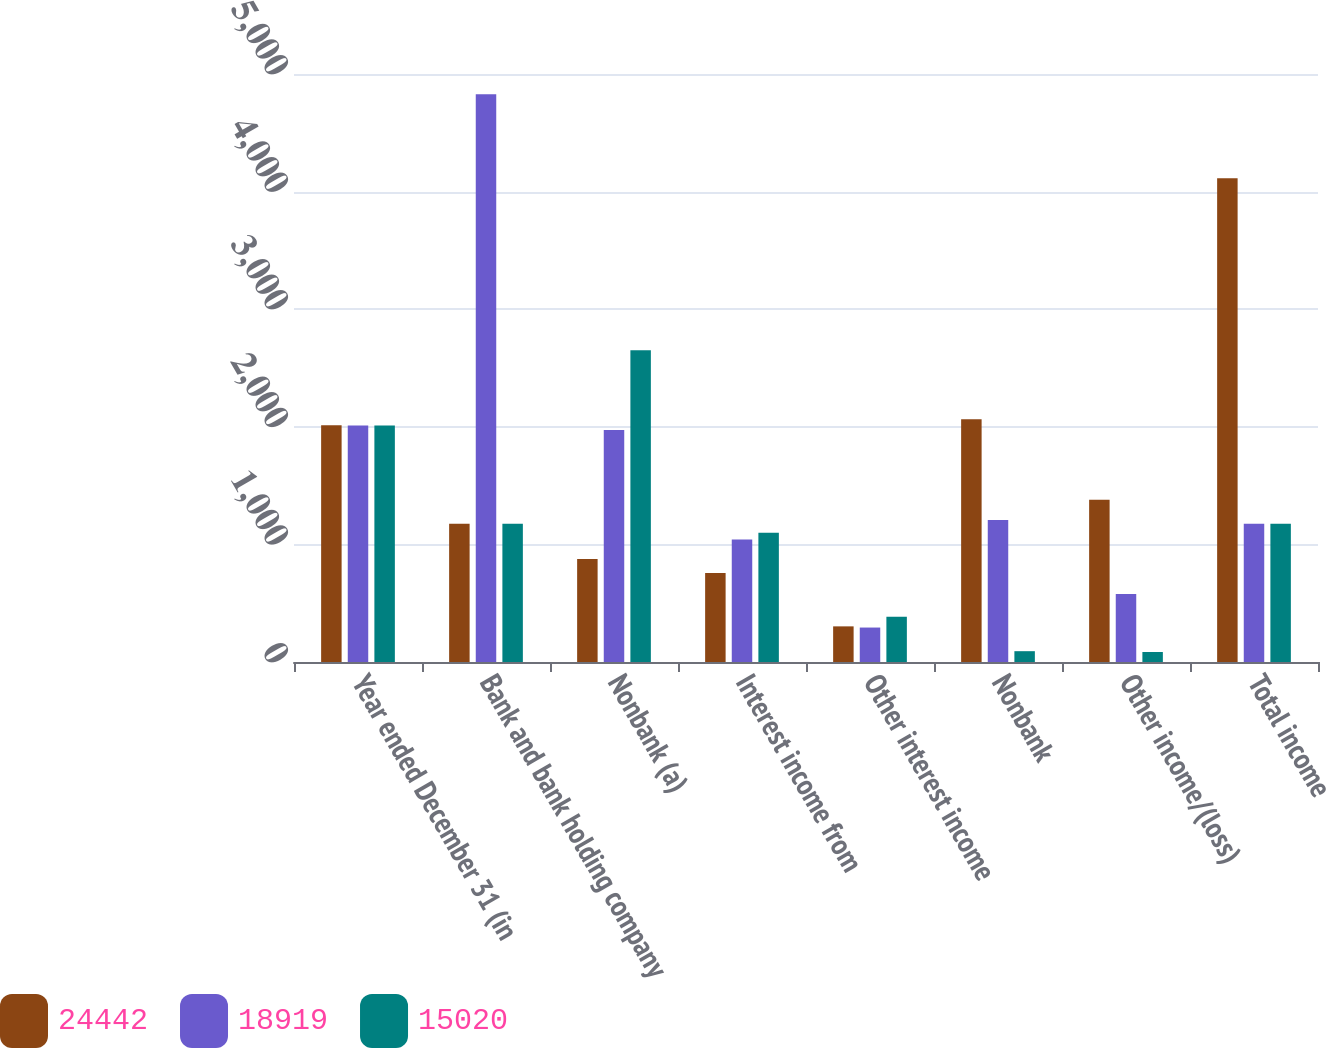<chart> <loc_0><loc_0><loc_500><loc_500><stacked_bar_chart><ecel><fcel>Year ended December 31 (in<fcel>Bank and bank holding company<fcel>Nonbank (a)<fcel>Interest income from<fcel>Other interest income<fcel>Nonbank<fcel>Other income/(loss)<fcel>Total income<nl><fcel>24442<fcel>2013<fcel>1175<fcel>876<fcel>757<fcel>303<fcel>2065<fcel>1380<fcel>4114<nl><fcel>18919<fcel>2012<fcel>4828<fcel>1972<fcel>1041<fcel>293<fcel>1207<fcel>579<fcel>1175<nl><fcel>15020<fcel>2011<fcel>1175<fcel>2651<fcel>1099<fcel>384<fcel>92<fcel>85<fcel>1175<nl></chart> 